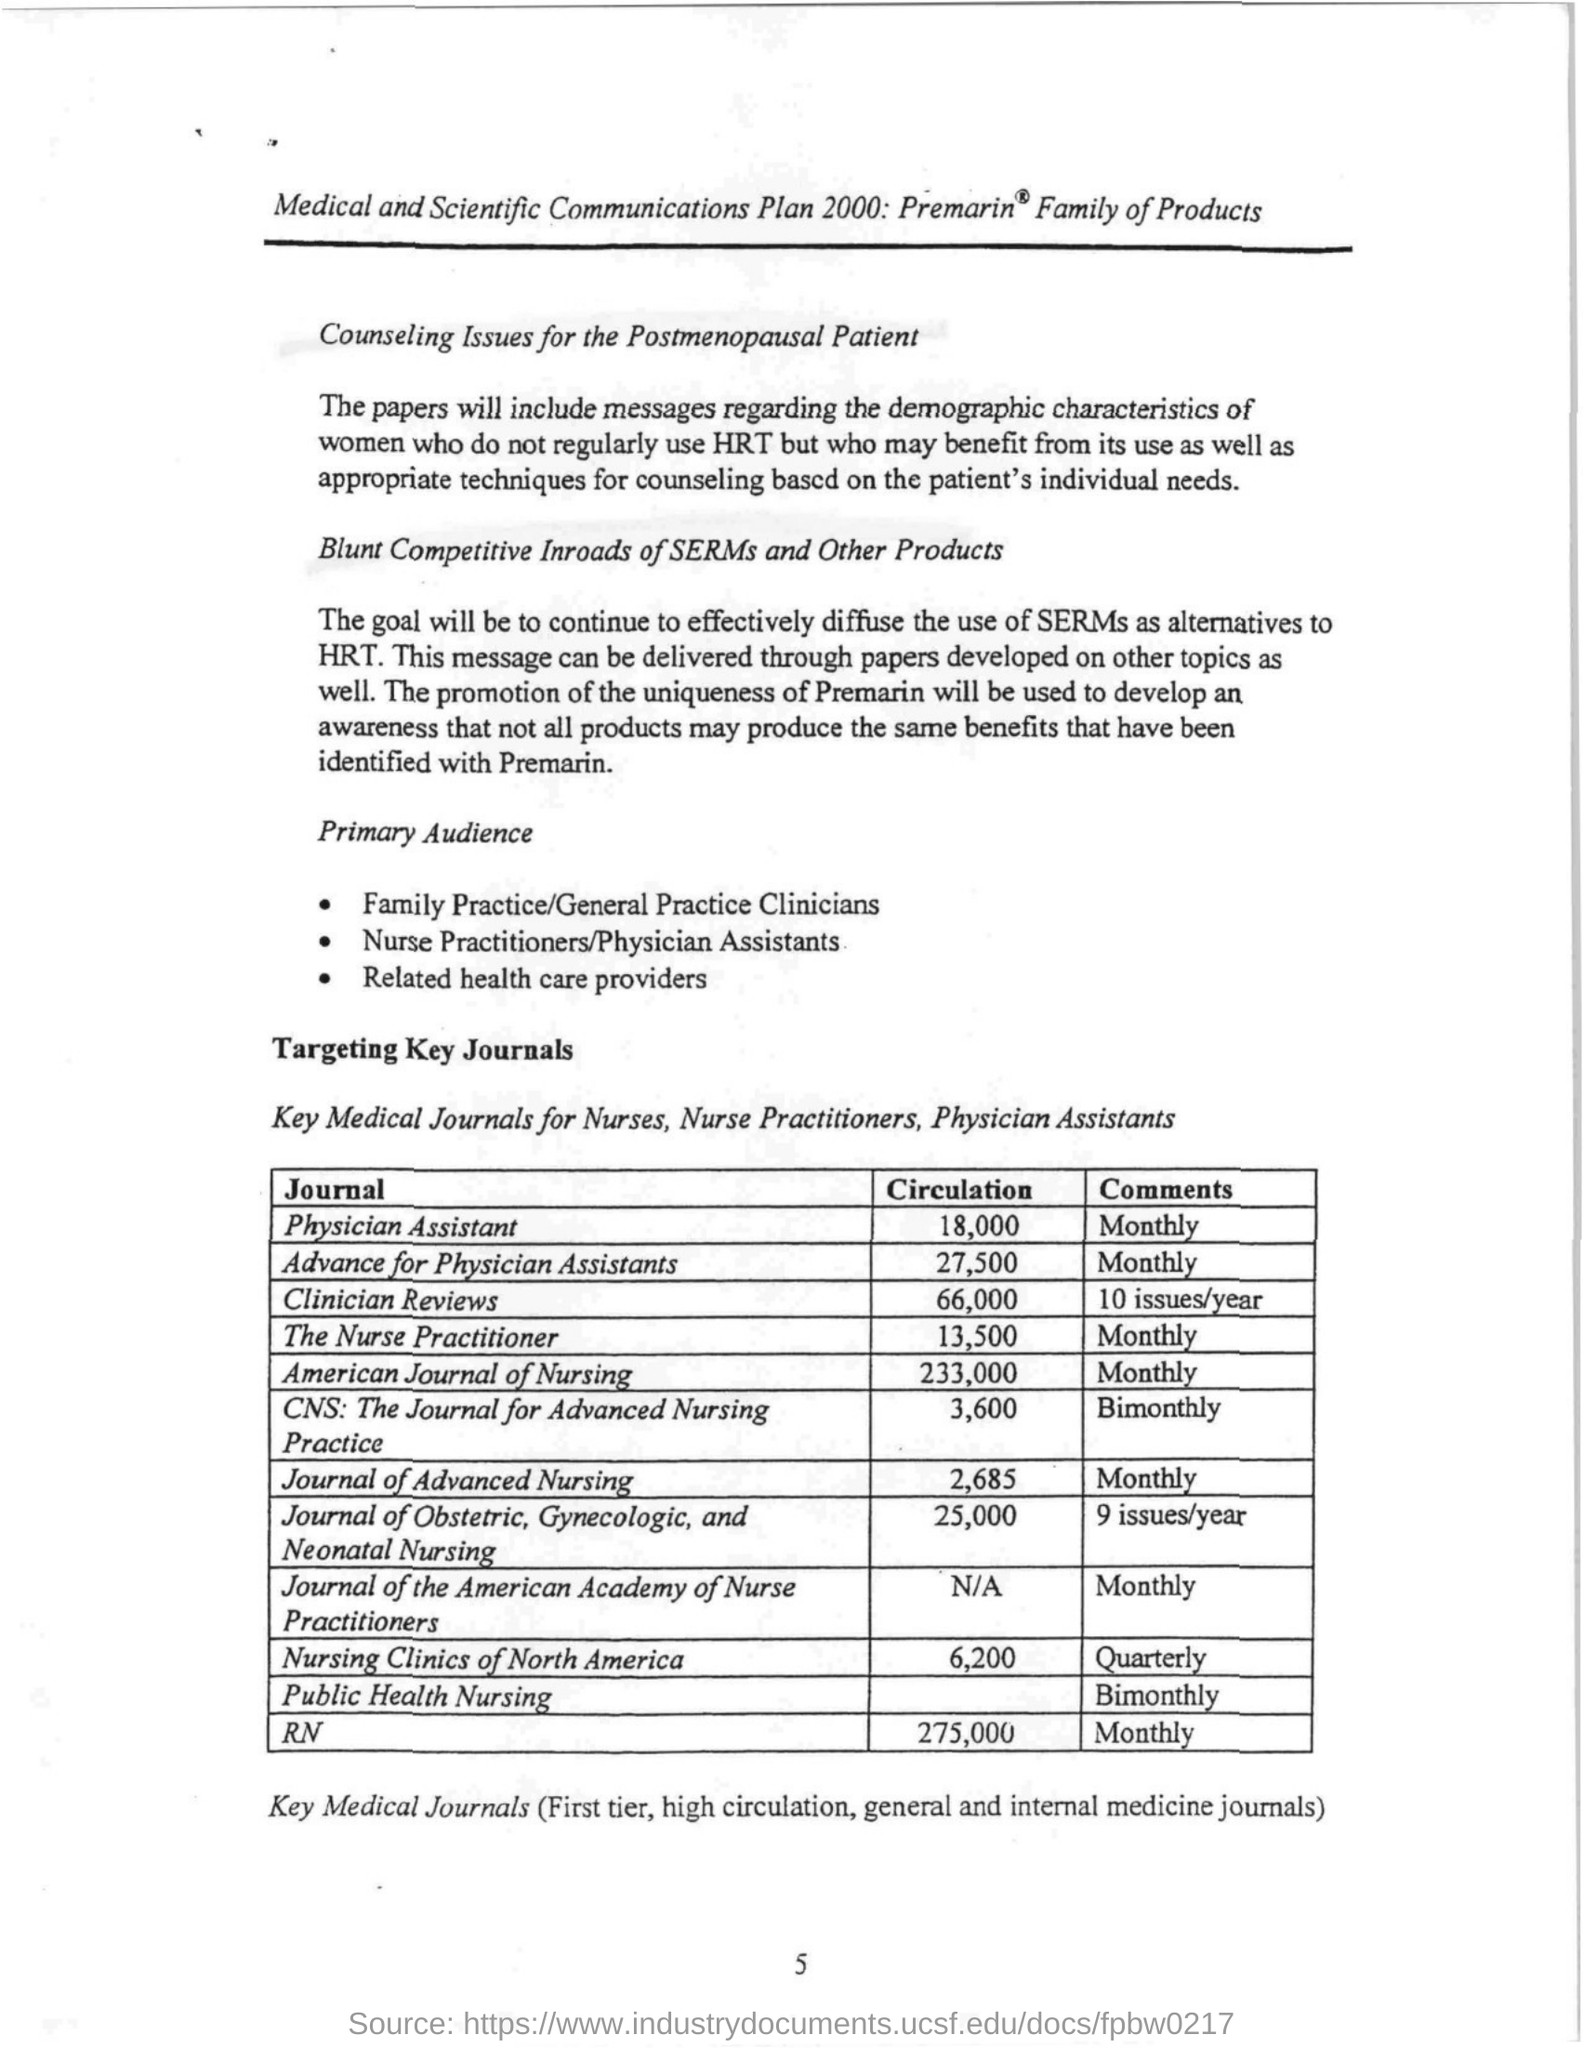Indicate a few pertinent items in this graphic. The American Journal of Nursing Monthly has 233,000 circulations. The circulation of the Journal of the American Academy of Nurse Practitioners has not been determined. The name of the Journal that contains quarterly comments about nursing is Nursing Clinics of North America. Clinician Reviews is a journal that is published 10 times per year. 